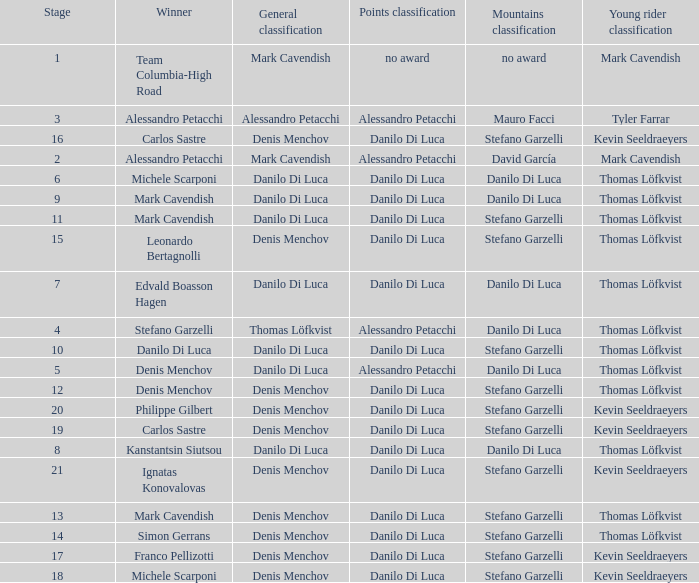When philippe gilbert is the winner who is the points classification? Danilo Di Luca. 